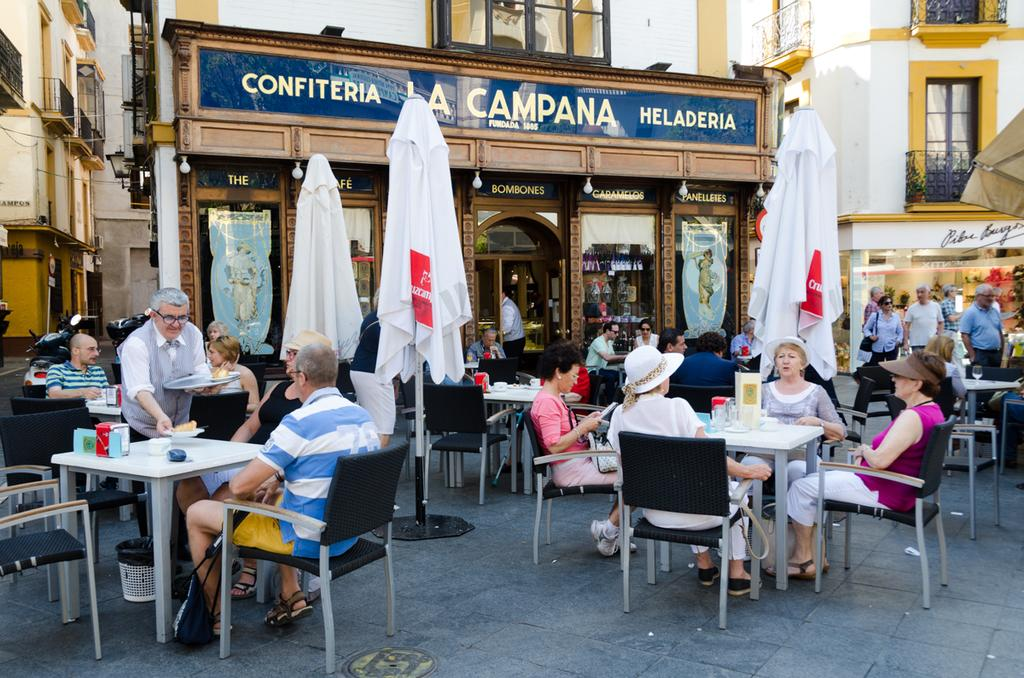How many people are in the image? There are people in the image, but the exact number is not specified. What are the people doing in the image? Some people are standing, while others are sitting on chairs. What type of furniture is present in the image? There are tables in the image. What can be seen in the background of the image? There are buildings in the image. Are there any vehicles visible in the image? Yes, there are vehicles in the image. Can you see any ants carrying a basin with their hands in the image? There are no ants, basins, or hands visible in the image. 